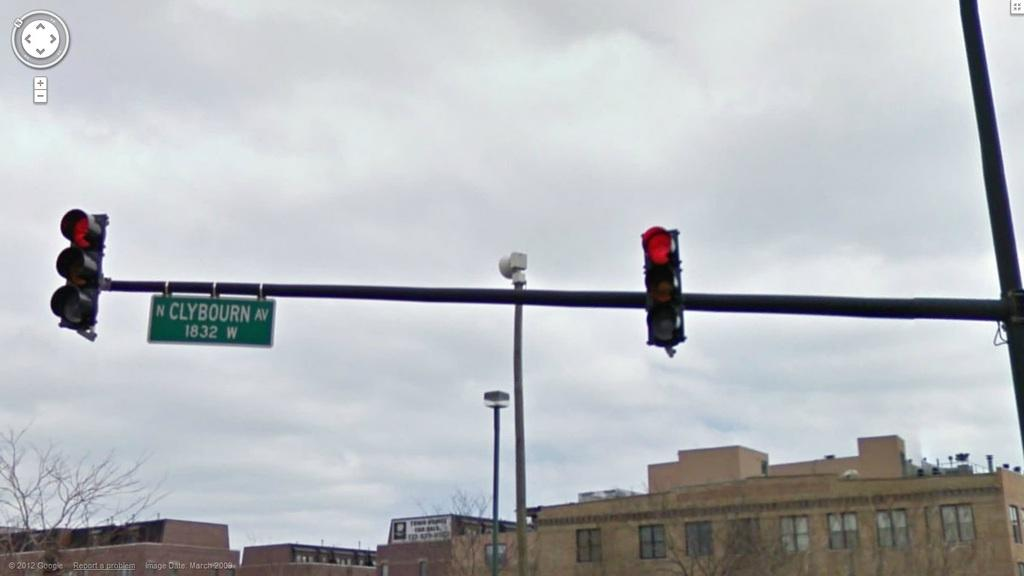<image>
Create a compact narrative representing the image presented. A traffic signal pole has a green street sign that says Clybourn Av. 